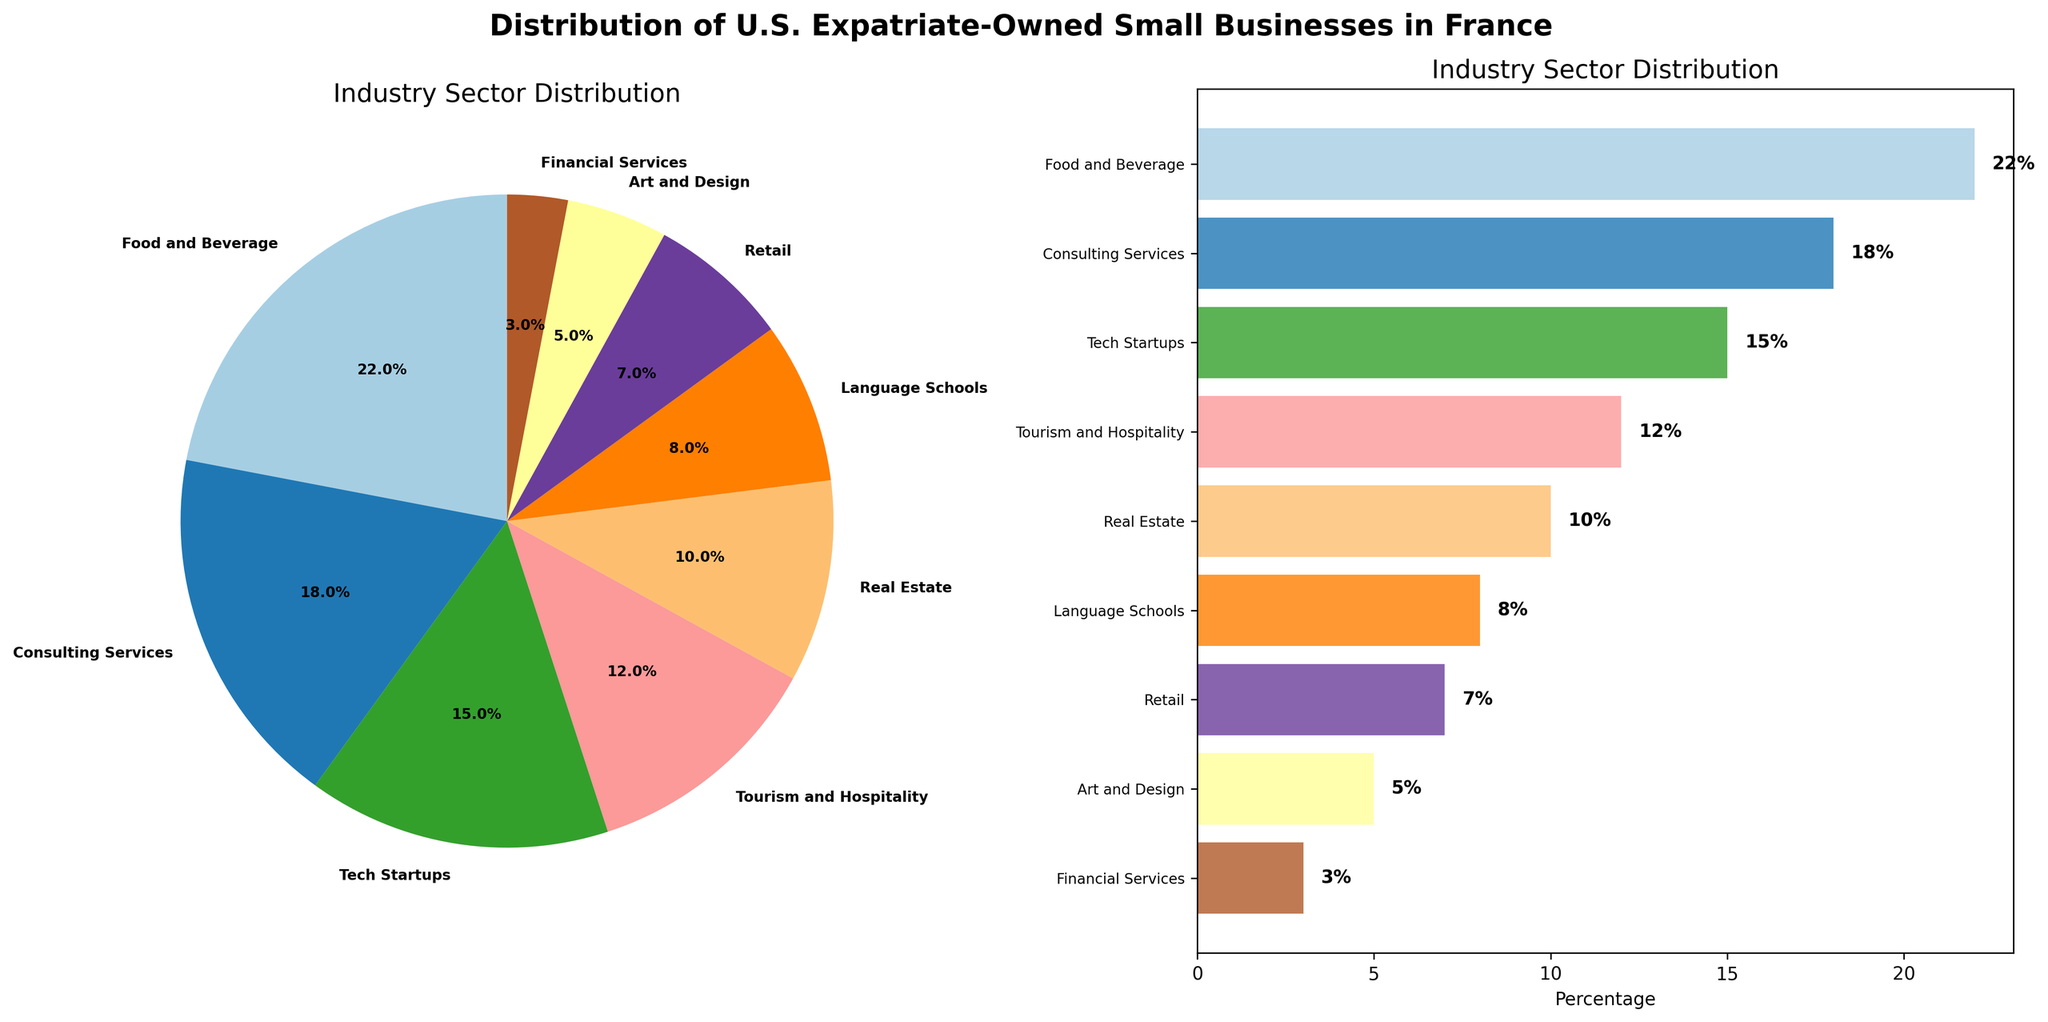What is the most represented industry sector for U.S. expatriate-owned small businesses in France? The pie chart and bar chart both show that the Food and Beverage sector has the largest segment.
Answer: Food and Beverage Which two industry sectors have the least representation? Both the pie and bar charts indicate that Financial Services and Art and Design have the smallest segments.
Answer: Financial Services and Art and Design What percentage of U.S. expatriate-owned small businesses in France are in the Tech Startups sector? Both charts show that the Tech Startups sector accounts for 15%.
Answer: 15% How much more significant is the Food and Beverage sector compared to Real Estate in percentage terms? The Food and Beverage sector is 22%, and Real Estate is 10%. The difference is 22% - 10% = 12%.
Answer: 12% Between Consulting Services and Language Schools, which sector has a higher percentage? Consulting Services shows 18% while Language Schools show 8%. So Consulting Services has a higher percentage.
Answer: Consulting Services What is the combined percentage of the three least represented sectors? Art and Design (5%), Financial Services (3%), and Retail (7%) together make up 5% + 3% + 7% = 15%.
Answer: 15% How does the percentage of businesses in Tourism and Hospitality compare to those in Consulting Services? Tourism and Hospitality is 12%, while Consulting Services is 18%. Consulting Services has 6% more.
Answer: Consulting Services has 6% more What is the total percentage of businesses in Food and Beverage, Tech Startups, and Real Estate combined? Combining these sectors: 22% (Food and Beverage) + 15% (Tech Startups) + 10% (Real Estate) = 47%.
Answer: 47% Which sector shows a percentage value less than half of the percentage of the Tech Startups sector? Tech Startups is 15%. Half of 15% is 7.5%. Both Language Schools (8%) and Retail (7%) fall around this range. Retail is below 7.5%, so it's less than half of Tech Startups.
Answer: Retail In which sectors do U.S. expatriate-owned businesses fall between 10% and 20%? The bar chart shows Consulting Services (18%), Tech Startups (15%), and Tourism and Hospitality (12%) fall in this range.
Answer: Consulting Services, Tech Startups, and Tourism and Hospitality 